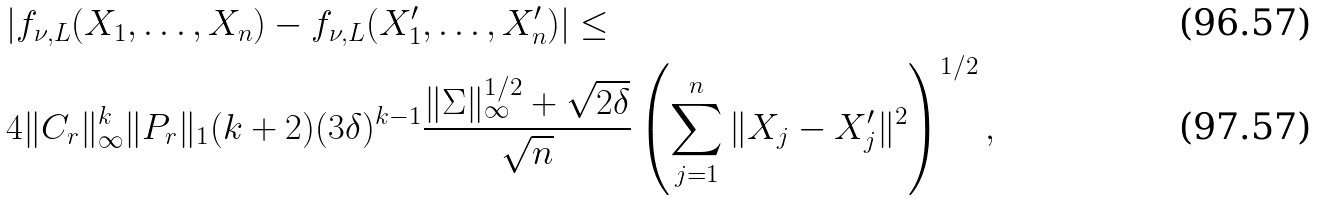<formula> <loc_0><loc_0><loc_500><loc_500>& | f _ { \nu , L } ( X _ { 1 } , \dots , X _ { n } ) - f _ { \nu , L } ( X _ { 1 } ^ { \prime } , \dots , X _ { n } ^ { \prime } ) | \leq \\ & 4 \| C _ { r } \| _ { \infty } ^ { k } \| P _ { r } \| _ { 1 } ( k + 2 ) ( 3 \delta ) ^ { k - 1 } \frac { \| \Sigma \| _ { \infty } ^ { 1 / 2 } + \sqrt { 2 \delta } } { \sqrt { n } } \left ( \sum _ { j = 1 } ^ { n } \| X _ { j } - X _ { j } ^ { \prime } \| ^ { 2 } \right ) ^ { 1 / 2 } ,</formula> 